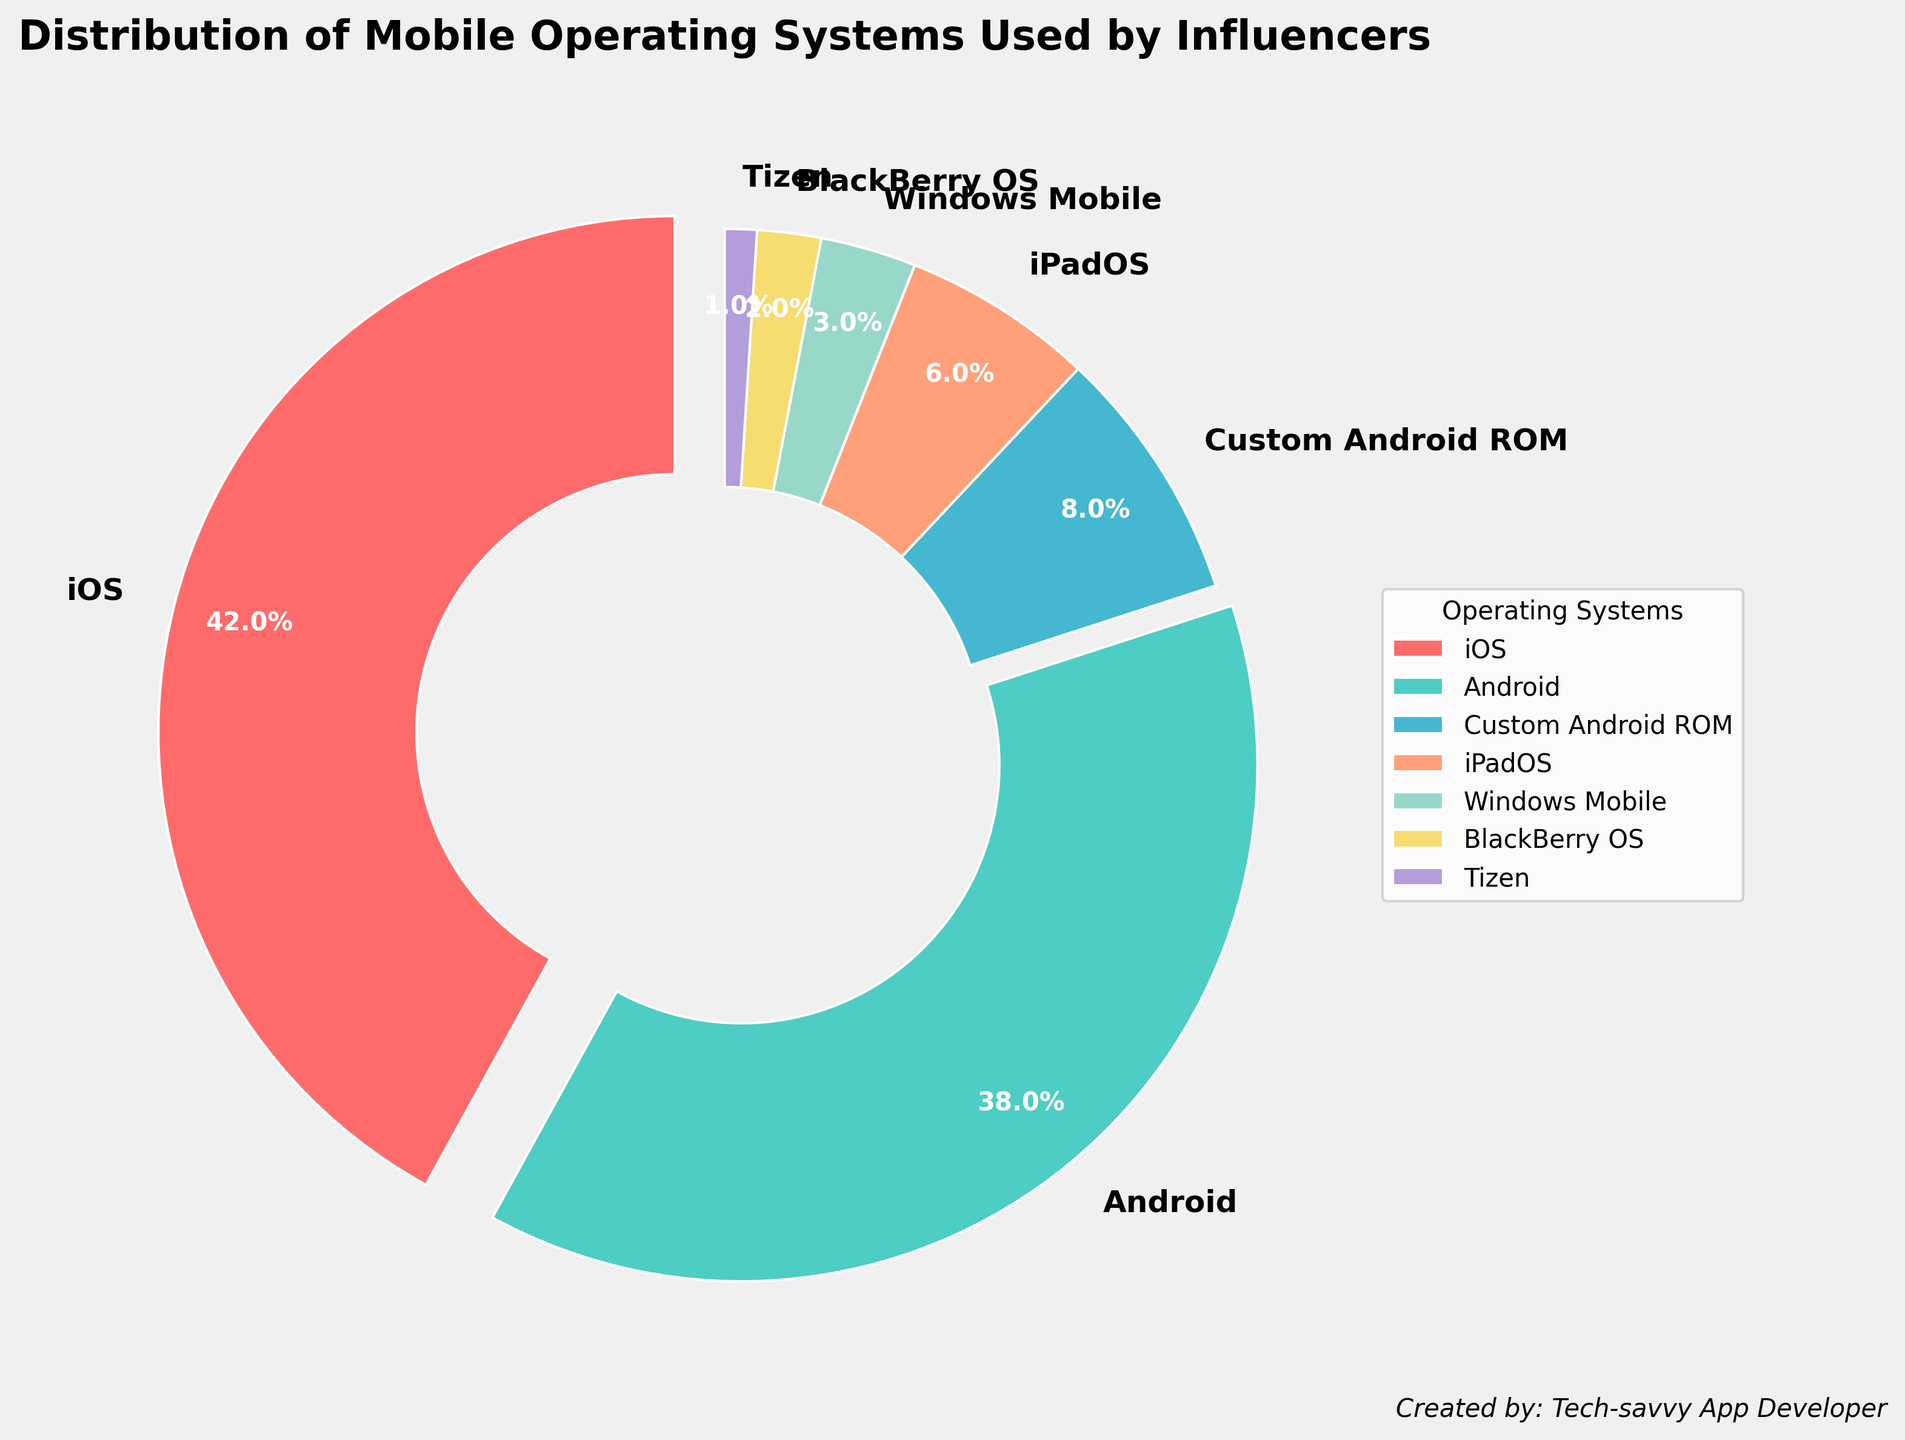What percentage of influencers use Android-based operating systems? Sum the percentages of both Android and Custom Android ROM as both are Android-based: 38% (Android) + 8% (Custom Android ROM) = 46%.
Answer: 46% Which mobile operating system has the highest percentage of users? Simply refer to the pie chart to identify the largest segment; iOS holds the largest portion at 42%.
Answer: iOS How much more popular is iOS compared to Windows Mobile among influencers? Subtract the percentage of Windows Mobile from iOS: 42% (iOS) - 3% (Windows Mobile) = 39%.
Answer: 39% What is the combined percentage of influencers using iOS, Android, and iPadOS? Sum the percentages of iOS, Android, and iPadOS: 42% + 38% + 6% = 86%.
Answer: 86% Is Custom Android ROM more popular than Windows Mobile? Compare the percentages directly: 8% (Custom Android ROM) > 3% (Windows Mobile).
Answer: Yes How many operating systems have a user percentage of less than 5%? Identify and count the operating systems with less than 5%: Windows Mobile (3%), BlackBerry OS (2%), and Tizen (1%). There are 3 such operating systems.
Answer: 3 Which two operating systems, when combined, are used by an equal percentage of influencers as iOS alone? Compare combined percentages with iOS: Android (38%) + iPadOS (6%) = 44%, which is close but more than iOS alone. Correct combination: Android (38%) + Custom Android ROM (8%) = 46%, which is higher. Optimal combination: iPadOS (6%) + Custom Android ROM + Windows Mobile = 8% + 3% = 17%, which is too low.
Answer: There is no exact combination equal to iOS alone What fraction of influencers use either BlackBerry OS or Tizen? Sum the percentages of both OS and convert to fraction: 2% (BlackBerry OS) + 1% (Tizen) = 3%. As a fraction, it's 3/100.
Answer: 3/100 If the total number of influencers surveyed is 1000, how many of them used iPadOS? Calculate the number by applying the percentage: 6% of 1000 = 0.06 * 1000 = 60.
Answer: 60 